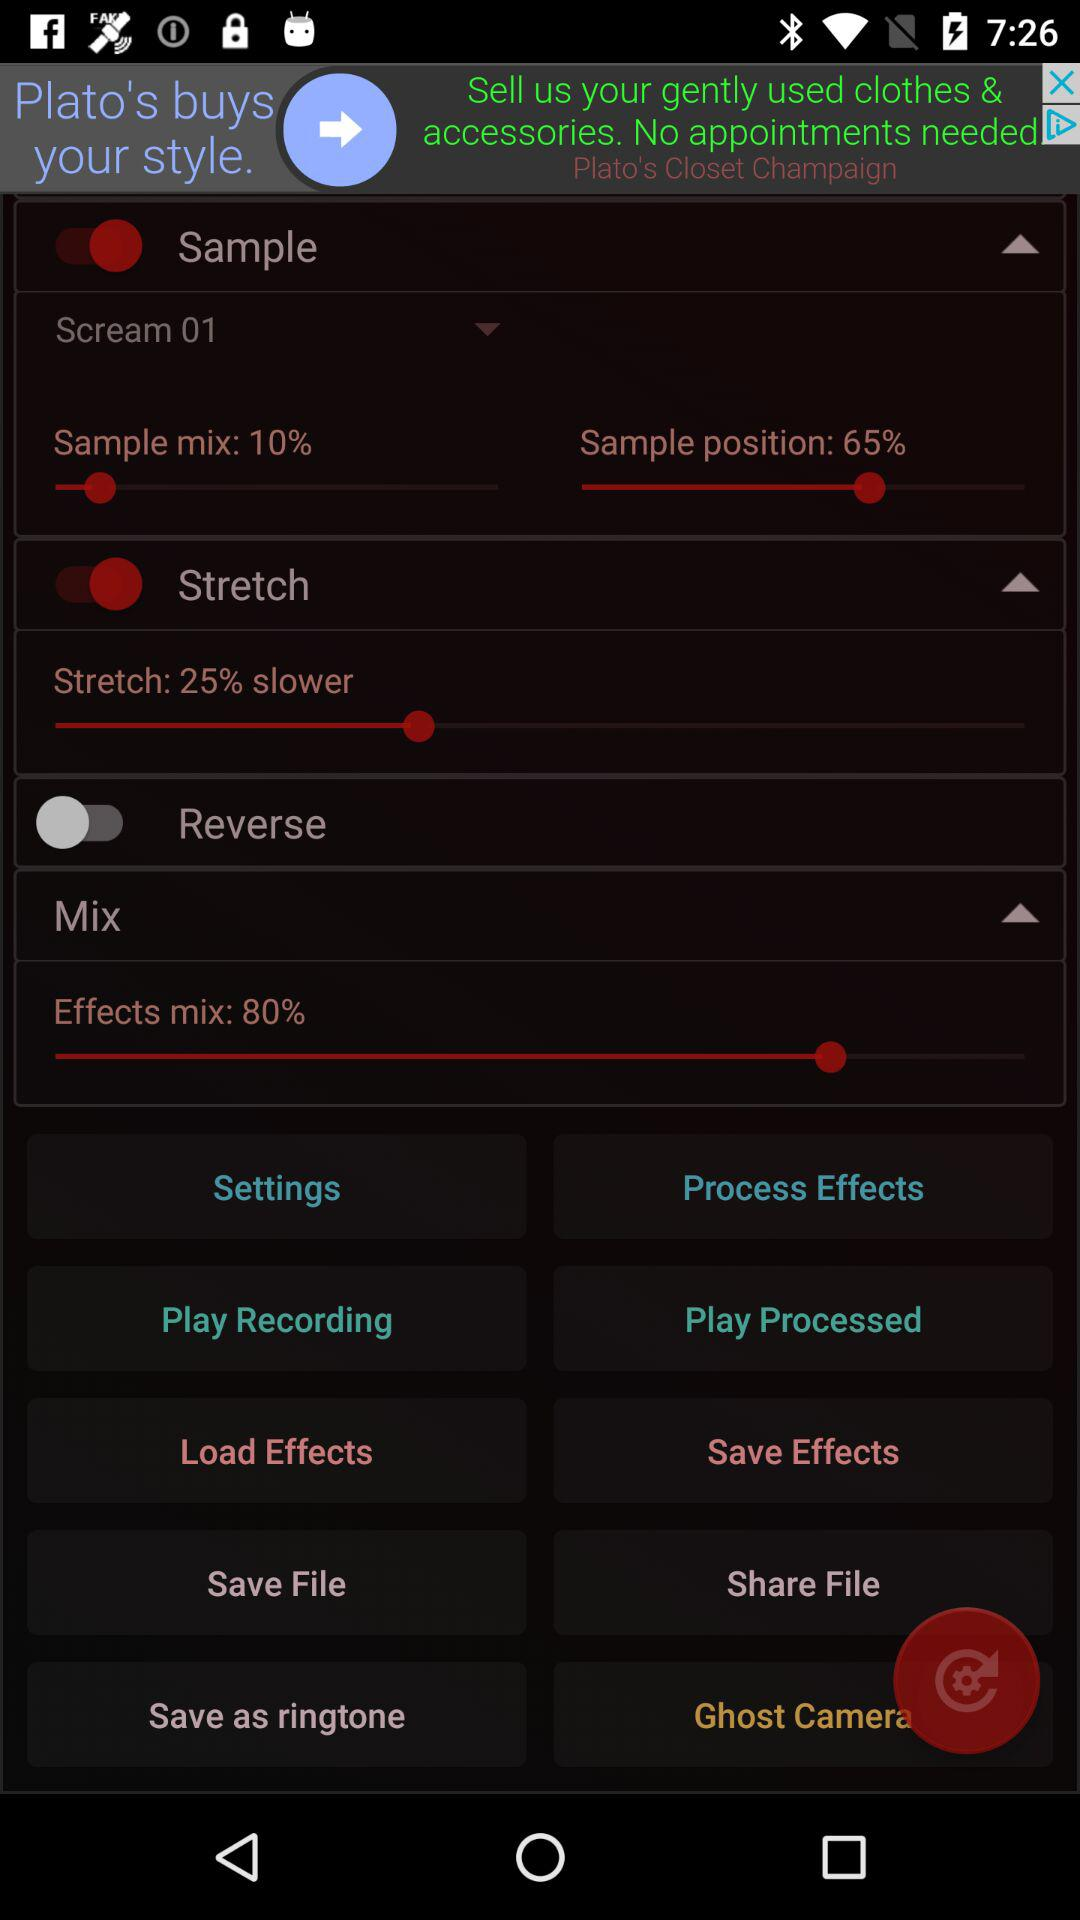What is the percentage of the sample position? The percentage of the sample position is 65. 